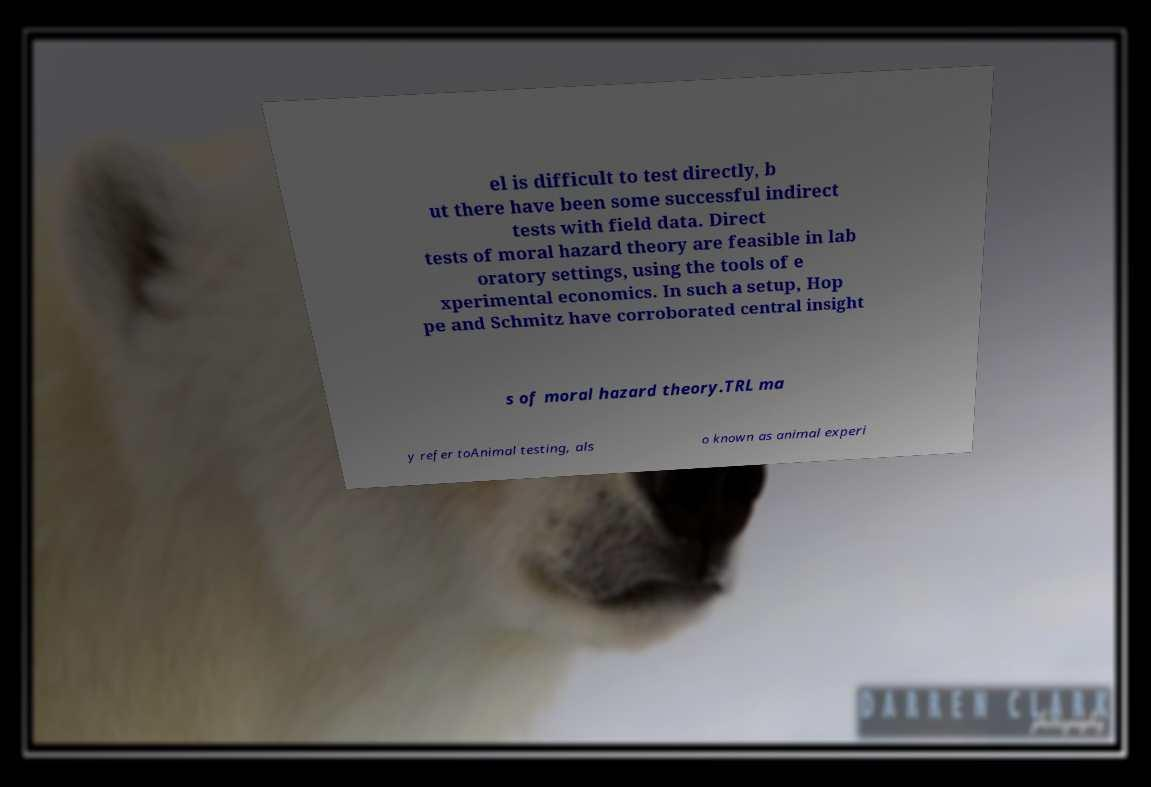For documentation purposes, I need the text within this image transcribed. Could you provide that? el is difficult to test directly, b ut there have been some successful indirect tests with field data. Direct tests of moral hazard theory are feasible in lab oratory settings, using the tools of e xperimental economics. In such a setup, Hop pe and Schmitz have corroborated central insight s of moral hazard theory.TRL ma y refer toAnimal testing, als o known as animal experi 